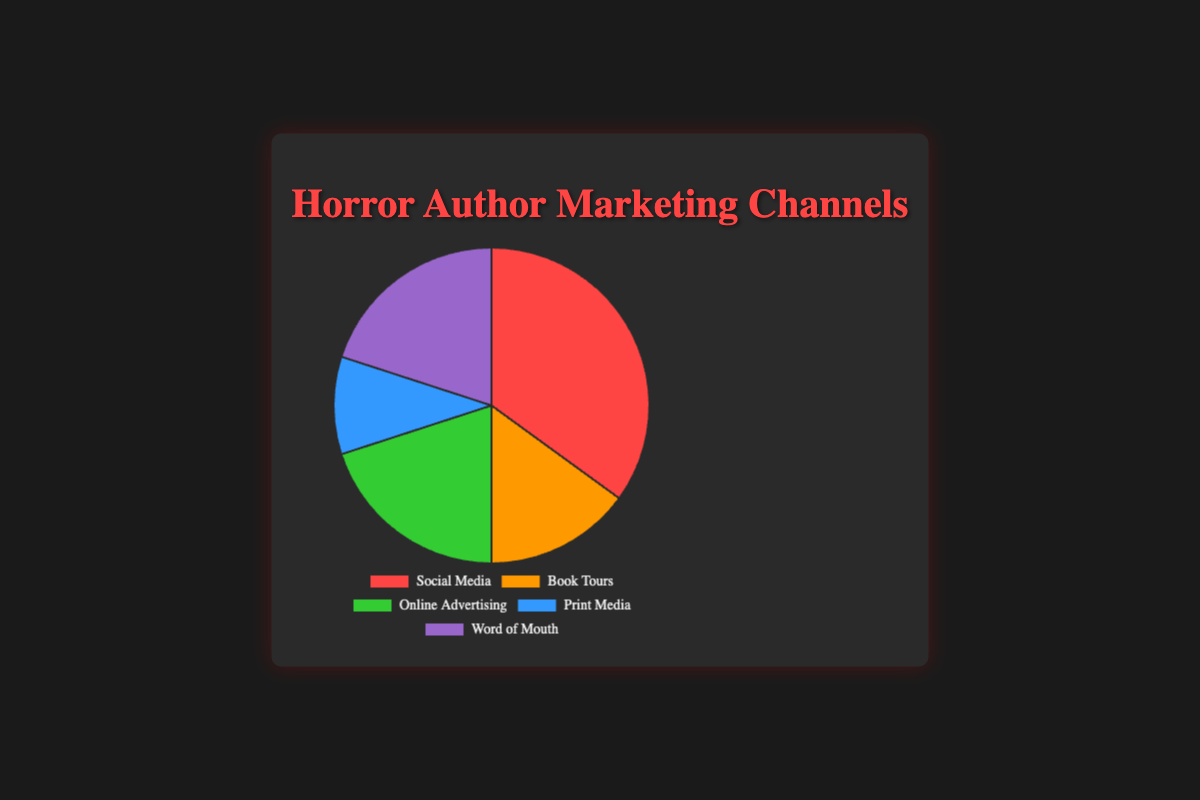What percentage of marketing channels is represented by Social Media? The chart shows that Social Media occupies 35% of the marketing channels utilized by horror authors.
Answer: 35% What is the total percentage of marketing channels used by authors for Online Advertising and Word of Mouth combined? Online Advertising is 20% and Word of Mouth is 20%. Adding these together gives 40%.
Answer: 40% How does the usage of Book Tours compare to Print Media in percentage terms? The chart shows that Book Tours account for 15%, while Print Media accounts for 10%. Thus, Book Tours are utilized 5% more than Print Media.
Answer: 5% more Which marketing channel has the second-highest percentage after Social Media? The chart shows Social Media has the highest percentage at 35%, followed by Online Advertising and Word of Mouth, both at 20%.
Answer: Online Advertising and Word of Mouth What is the combined percentage of all marketing channels except for Social Media? The percentage of Social Media is 35%, so the combined percentage of the other channels is 100% - 35% = 65%.
Answer: 65% What fraction of the total marketing channels does Print Media represent? Print Media represents 10% of the total, which is 10/100 = 1/10 or 0.10 as a fraction.
Answer: 1/10 or 0.10 What is the difference between the highest and lowest utilized marketing channels? The highest is Social Media at 35%, and the lowest is Print Media at 10%. The difference is 35% - 10% = 25%.
Answer: 25% Are Book Tours utilized more or less than Online Advertising by horror authors, and by how much? Book Tours are utilized at 15%, while Online Advertising is at 20%. Therefore, Online Advertising is utilized 5% more than Book Tours.
Answer: 5% more If the percentage for Word of Mouth was to increase by 10%, what would the new percentage be and how would it affect the total remaining percentage? Increasing Word of Mouth by 10% changes it to 30%. If Word of Mouth increases by 10%, the total remaining percentage would drop by 10% from 80% to 70%.
Answer: 30% and 70% What color is used to represent Online Advertising in the pie chart? The pie chart uses green to represent Online Advertising.
Answer: Green 